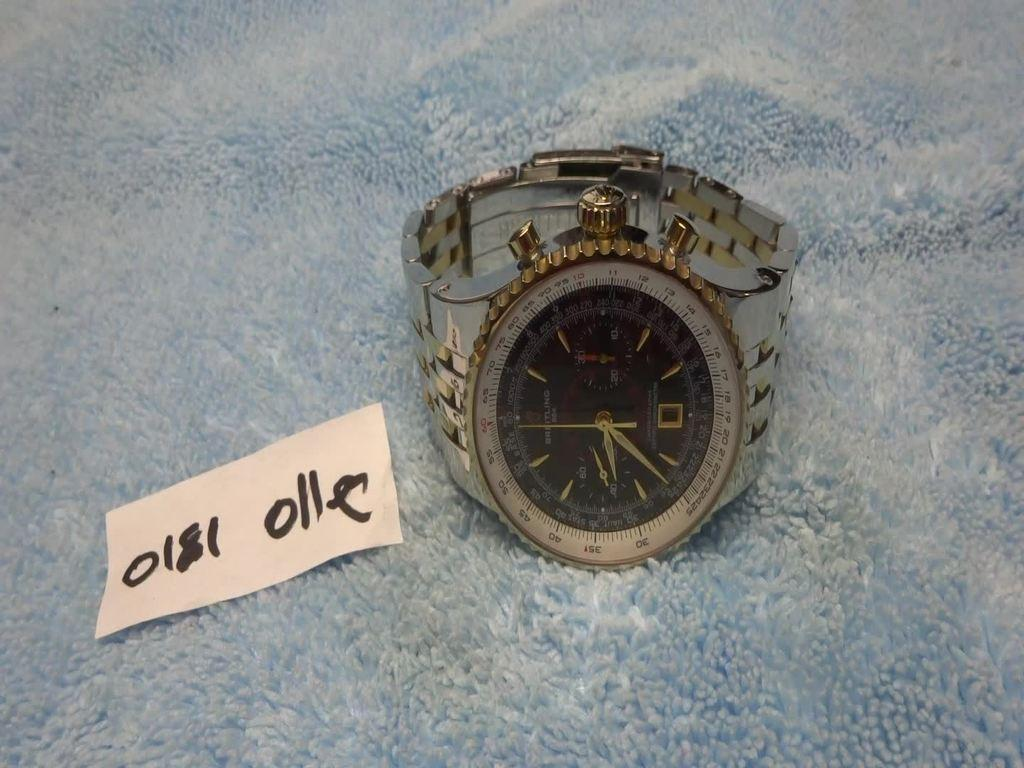What is the main subject in the center of the image? There is a watch in the center of the image. Can you describe any additional details about the watch? Unfortunately, the provided facts do not mention any additional details about the watch. What is attached to the cloth in the image? There is a price tag on the cloth. How does the watch feel about the upcoming meeting in the image? Watches do not have feelings or attend meetings, so this question cannot be answered based on the provided facts. 